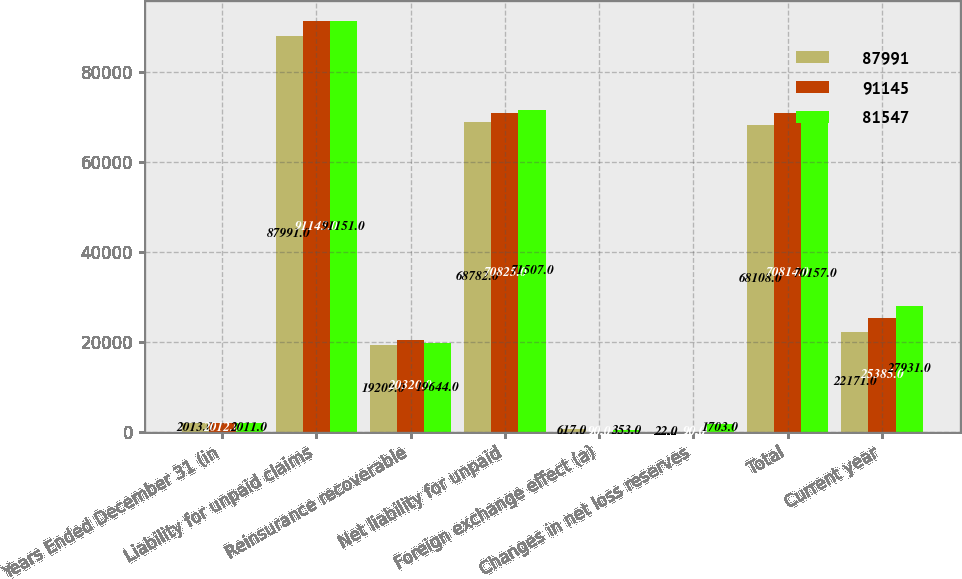Convert chart to OTSL. <chart><loc_0><loc_0><loc_500><loc_500><stacked_bar_chart><ecel><fcel>Years Ended December 31 (in<fcel>Liability for unpaid claims<fcel>Reinsurance recoverable<fcel>Net liability for unpaid<fcel>Foreign exchange effect (a)<fcel>Changes in net loss reserves<fcel>Total<fcel>Current year<nl><fcel>87991<fcel>2013<fcel>87991<fcel>19209<fcel>68782<fcel>617<fcel>22<fcel>68108<fcel>22171<nl><fcel>91145<fcel>2012<fcel>91145<fcel>20320<fcel>70825<fcel>90<fcel>90<fcel>70814<fcel>25385<nl><fcel>81547<fcel>2011<fcel>91151<fcel>19644<fcel>71507<fcel>353<fcel>1703<fcel>70157<fcel>27931<nl></chart> 